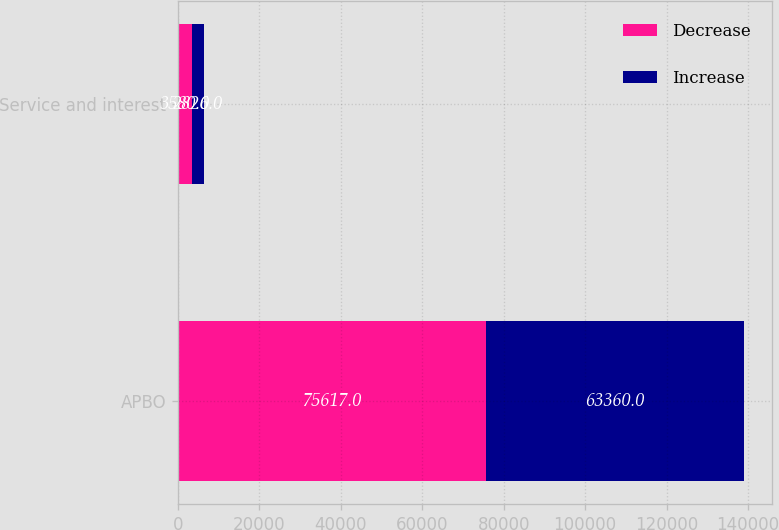Convert chart. <chart><loc_0><loc_0><loc_500><loc_500><stacked_bar_chart><ecel><fcel>APBO<fcel>Service and interest<nl><fcel>Decrease<fcel>75617<fcel>3580<nl><fcel>Increase<fcel>63360<fcel>2826<nl></chart> 